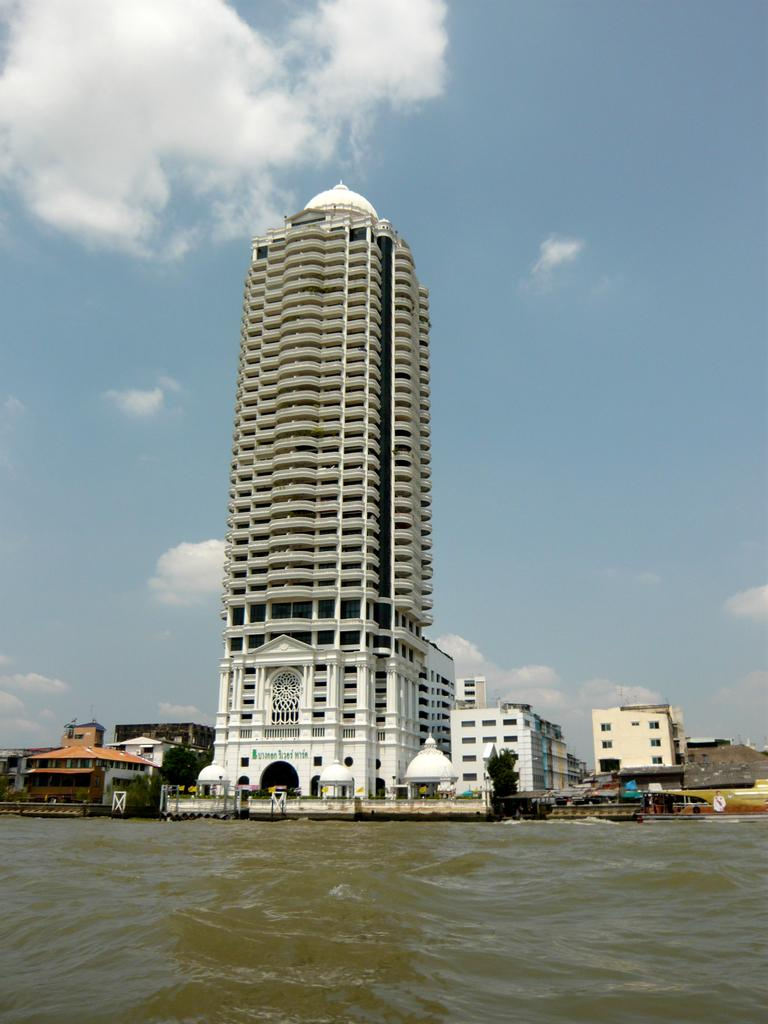What is located at the bottom of the image? There is a sea at the bottom of the image. What can be seen in the background of the image? There are buildings in the background of the image. What is visible at the top of the image? There is a sky at the top of the image. How many kittens are playing near the sea in the image? There are no kittens present in the image. Is there a boat visible in the sea in the image? There is no boat visible in the sea in the image. 